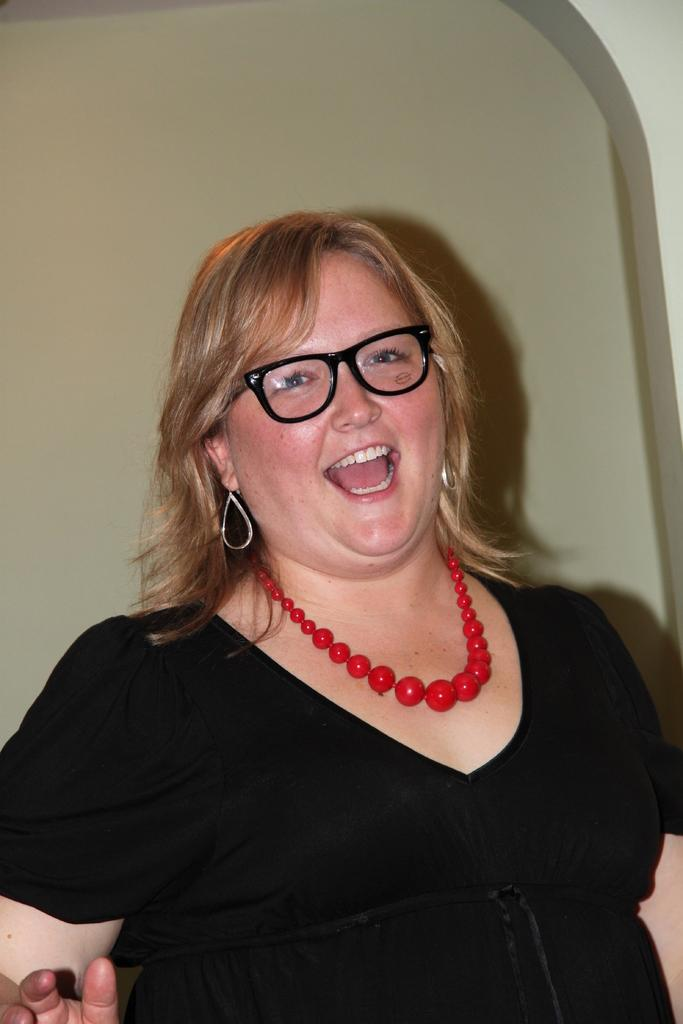What is the main subject in the foreground of the image? There is a woman in the foreground of the image. What is the woman wearing? The woman is wearing a black dress. What is the woman doing in the image? The woman has her mouth open. What can be seen in the background of the image? There is a wall in the background of the image. What type of texture can be seen on the woman's dress in the image? The provided facts do not mention the texture of the woman's dress, so it cannot be determined from the image. 